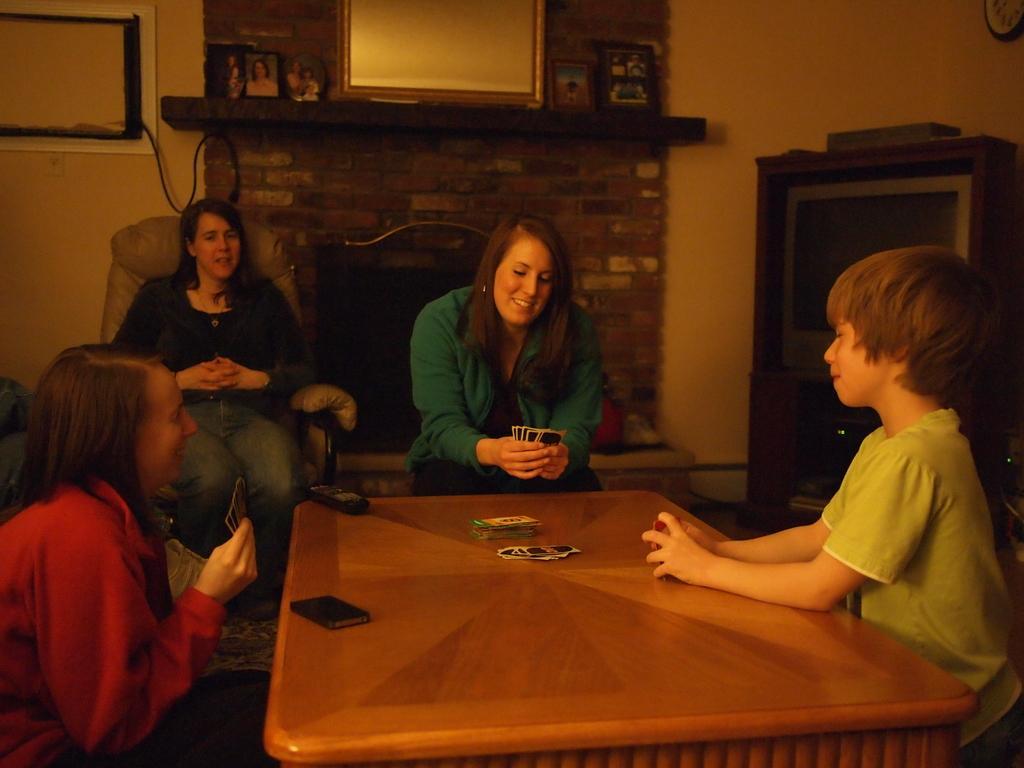Could you give a brief overview of what you see in this image? This picture describes about four people seated on the chair, in the middle of the given image a woman is playing cards, in the background we can see mirror and a television. 